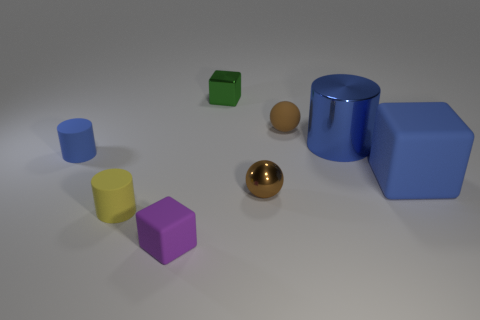There is another cylinder that is the same color as the shiny cylinder; what size is it?
Your answer should be very brief. Small. Is the number of cubes that are on the left side of the blue shiny cylinder less than the number of tiny purple rubber blocks that are behind the tiny rubber block?
Provide a succinct answer. No. What number of other objects are the same size as the green metal thing?
Give a very brief answer. 5. There is a blue rubber object that is to the right of the brown ball that is on the left side of the rubber ball that is in front of the green metal object; what shape is it?
Ensure brevity in your answer.  Cube. What number of gray objects are either tiny rubber objects or matte cubes?
Offer a very short reply. 0. What number of yellow rubber things are left of the small cylinder that is to the left of the yellow cylinder?
Keep it short and to the point. 0. Is there anything else of the same color as the matte sphere?
Give a very brief answer. Yes. There is a tiny purple thing that is the same material as the small yellow cylinder; what is its shape?
Your answer should be very brief. Cube. Do the small rubber ball and the big rubber block have the same color?
Offer a terse response. No. Is the material of the brown thing right of the brown metallic thing the same as the small ball in front of the brown matte ball?
Provide a short and direct response. No. 